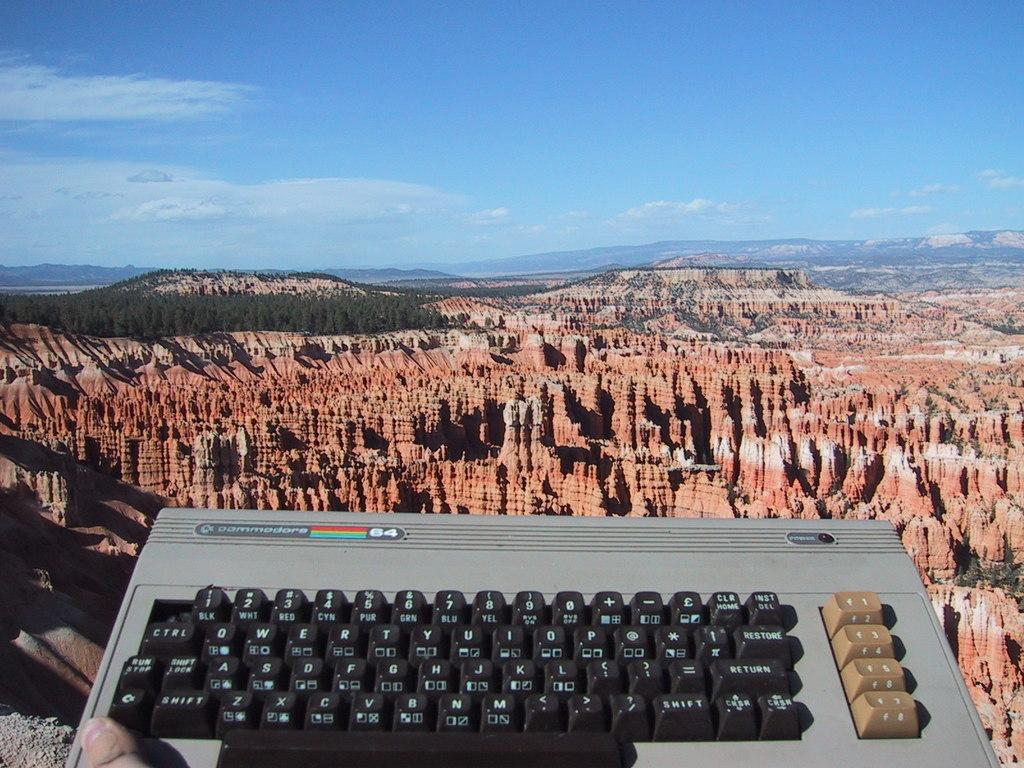<image>
Offer a succinct explanation of the picture presented. Keyboard with the number 64 on it in front of a view of mountains. 